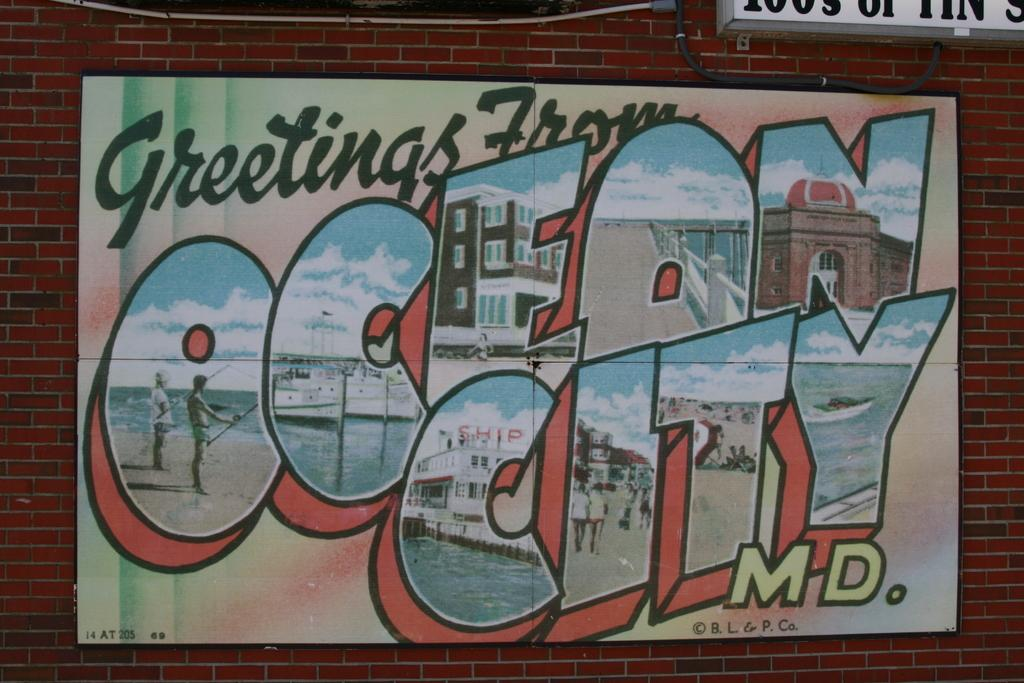<image>
Present a compact description of the photo's key features. A large postcard painting for Ocean City, MD is against a brick building. 